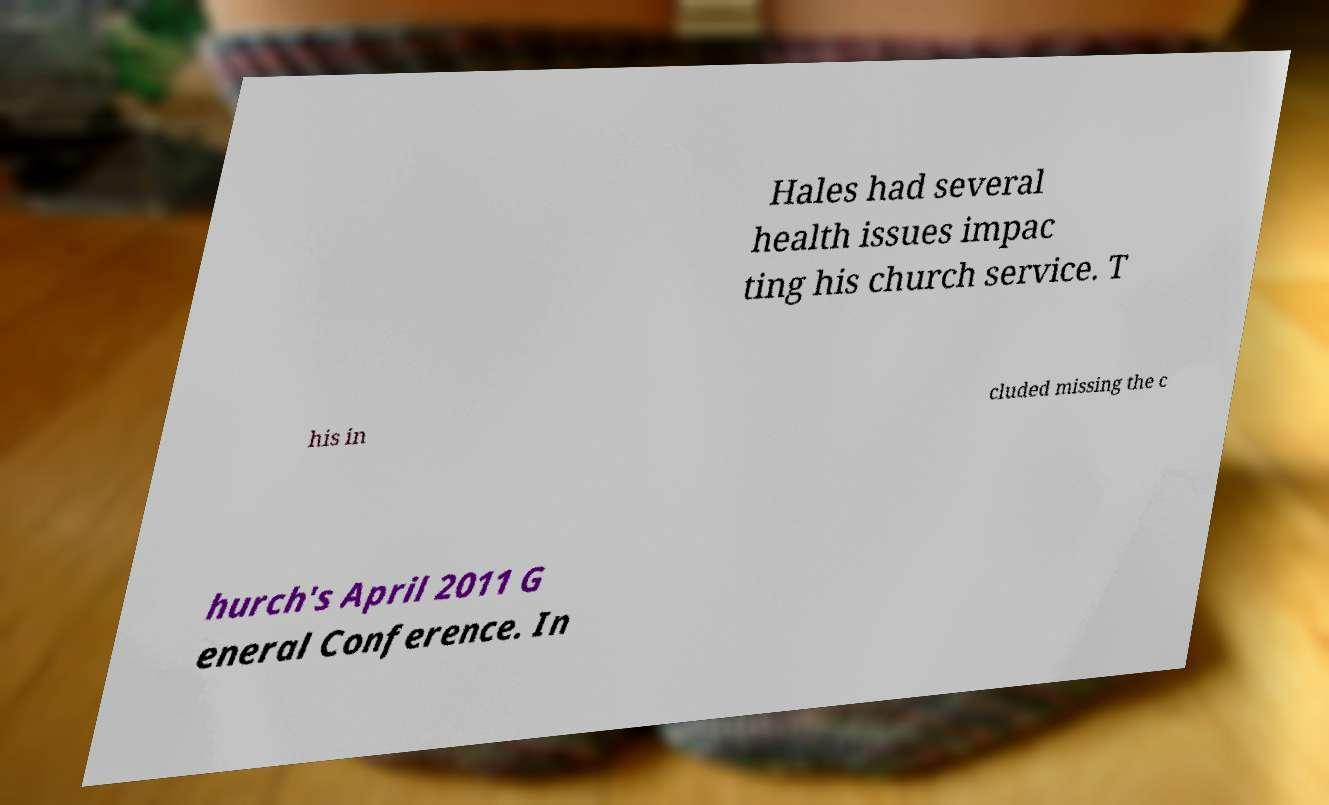Can you read and provide the text displayed in the image?This photo seems to have some interesting text. Can you extract and type it out for me? Hales had several health issues impac ting his church service. T his in cluded missing the c hurch's April 2011 G eneral Conference. In 